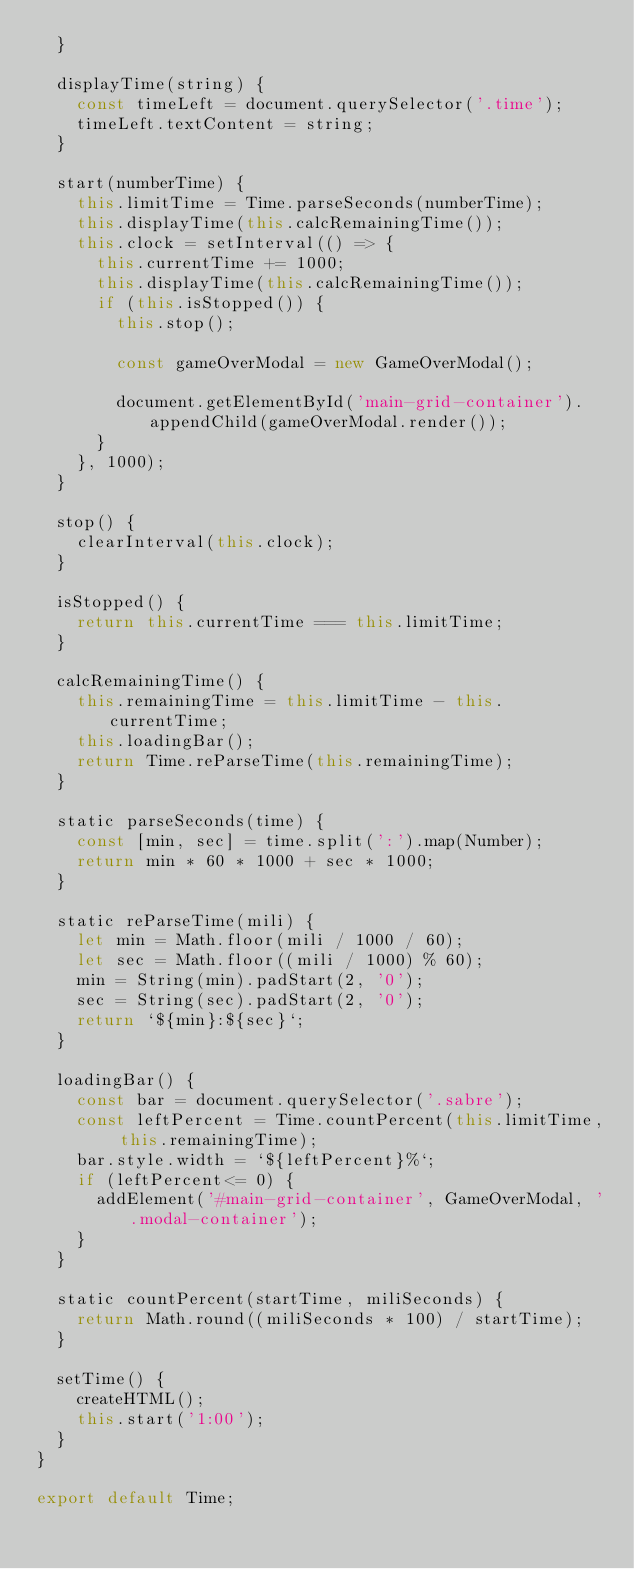Convert code to text. <code><loc_0><loc_0><loc_500><loc_500><_JavaScript_>  }

  displayTime(string) {
    const timeLeft = document.querySelector('.time');
    timeLeft.textContent = string;
  }

  start(numberTime) {
    this.limitTime = Time.parseSeconds(numberTime);
    this.displayTime(this.calcRemainingTime());
    this.clock = setInterval(() => {
      this.currentTime += 1000;
      this.displayTime(this.calcRemainingTime());
      if (this.isStopped()) {
        this.stop();

        const gameOverModal = new GameOverModal();

        document.getElementById('main-grid-container').appendChild(gameOverModal.render());
      }
    }, 1000);
  }

  stop() {
    clearInterval(this.clock);
  }

  isStopped() {
    return this.currentTime === this.limitTime;
  }

  calcRemainingTime() {
    this.remainingTime = this.limitTime - this.currentTime;
    this.loadingBar();
    return Time.reParseTime(this.remainingTime);
  }

  static parseSeconds(time) {
    const [min, sec] = time.split(':').map(Number);
    return min * 60 * 1000 + sec * 1000;
  }

  static reParseTime(mili) {
    let min = Math.floor(mili / 1000 / 60);
    let sec = Math.floor((mili / 1000) % 60);
    min = String(min).padStart(2, '0');
    sec = String(sec).padStart(2, '0');
    return `${min}:${sec}`;
  }

  loadingBar() {
    const bar = document.querySelector('.sabre');
    const leftPercent = Time.countPercent(this.limitTime, this.remainingTime);
    bar.style.width = `${leftPercent}%`;
    if (leftPercent<= 0) {
      addElement('#main-grid-container', GameOverModal, '.modal-container');
    }
  }

  static countPercent(startTime, miliSeconds) {
    return Math.round((miliSeconds * 100) / startTime);
  }

  setTime() {
    createHTML();
    this.start('1:00');
  }
}

export default Time;
</code> 